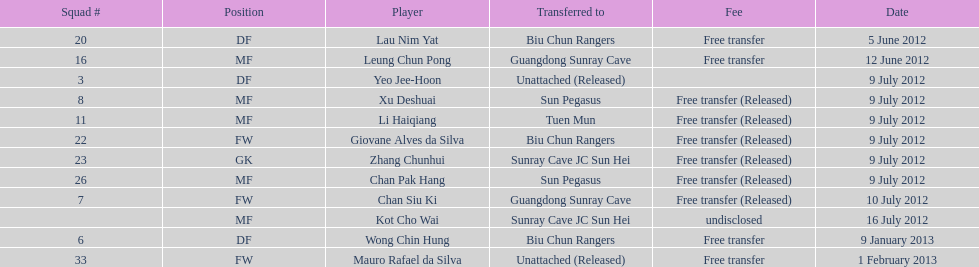Which player was transferred right before mauro rafael da silva? Wong Chin Hung. 